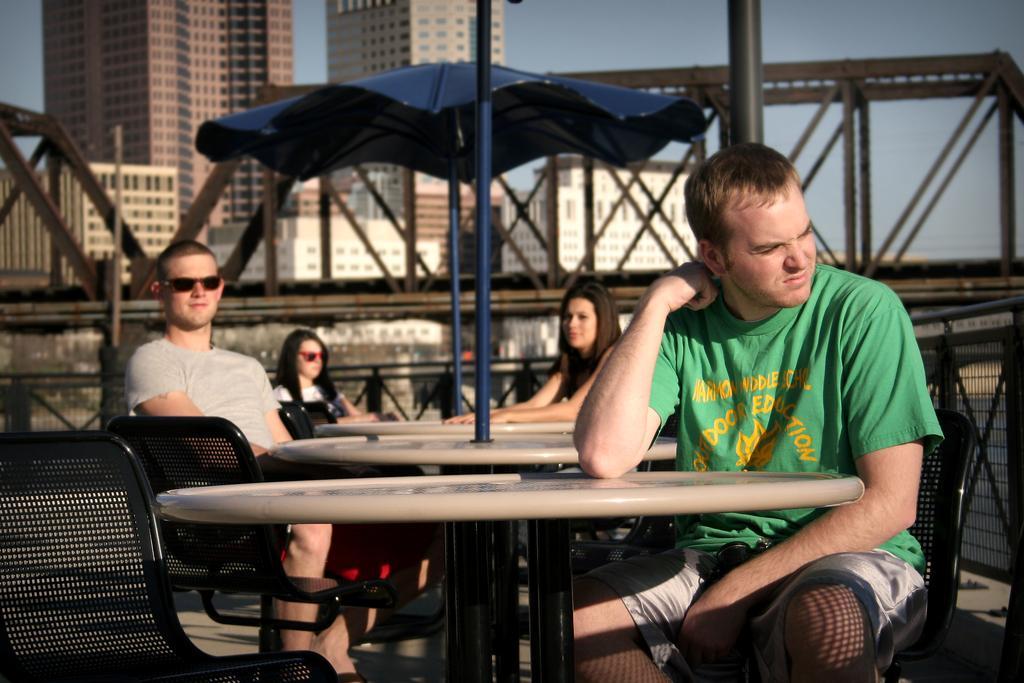Please provide a concise description of this image. In this image I can see four people sitting on the chairs. In the background there is a building and the sky. 